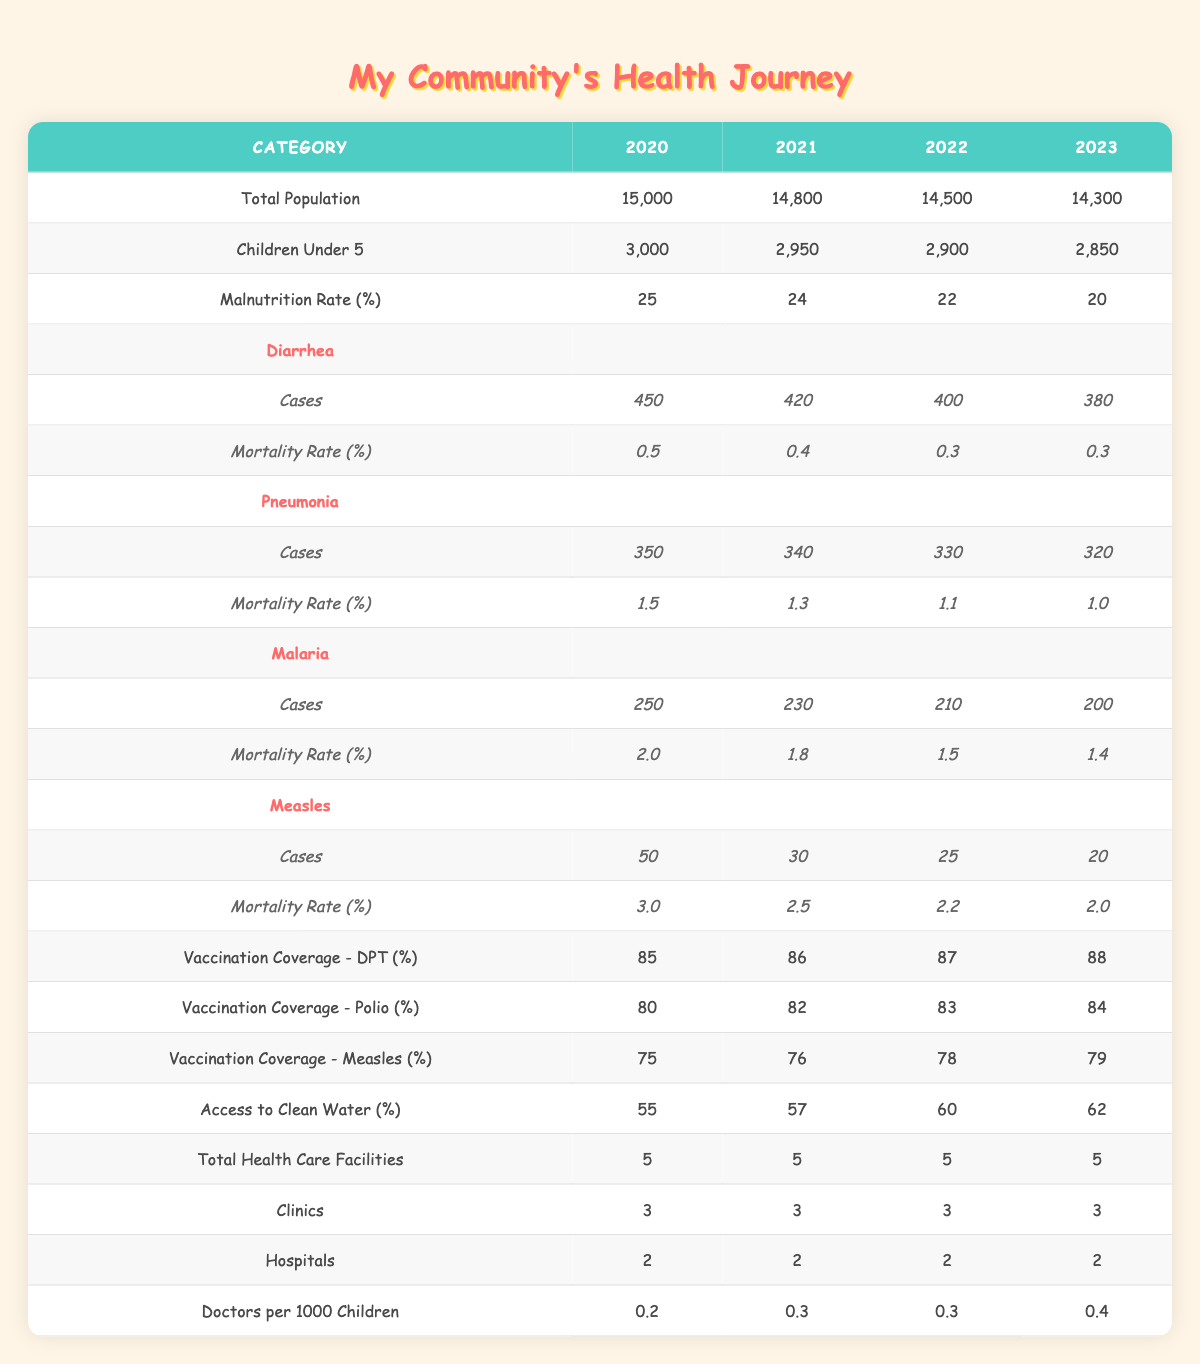What was the malnutrition rate in 2022? The malnutrition rate can be found in the table, specifically under the "Malnutrition Rate (%)" row for the year 2022. It shows a value of 22%.
Answer: 22% How many cases of pneumonia were reported in 2021? The number of pneumonia cases for the year 2021 can be retrieved from the "Pneumonia" section, where it states there were 340 cases in that year.
Answer: 340 What is the percentage of the total population under 5 years old in 2023? To find this percentage, I refer to the number of children under 5 (2,850) and total population (14,300) in 2023. The percentage is calculated as (2,850 / 14,300) * 100, which equals about 19.9%.
Answer: 19.9% What is the average mortality rate for measles over the four years? To calculate the average mortality rate for measles, we look at the mortality rates from 2020 to 2023: 3.0, 2.5, 2.2, and 2.0. Adding these values gives us 9.7, and dividing this by 4 (the number of years) results in an average of 2.425%.
Answer: 2.425% Did the access to clean water percentage improve from 2020 to 2023? To determine whether access to clean water improved, we compare the percentage in 2020 (55%) with that in 2023 (62%). Since 62% is greater than 55%, access to clean water has indeed improved.
Answer: Yes What is the total number of cases for diarrhea, pneumonia, malaria, and measles in 2022? To find the total cases, we add the reported cases of each illness for 2022: Diarrhea (400), Pneumonia (330), Malaria (210), and Measles (25). The total is 400 + 330 + 210 + 25 = 965.
Answer: 965 How many doctors are available per 1000 children in the community in 2023? The number of doctors per 1000 children in 2023 can be directly found in the "Doctors per 1000 Children" row for that year, which shows a value of 0.4.
Answer: 0.4 What was the trend for vaccination coverage for DPT from 2020 to 2023? Looking at the DPT vaccination coverage data in the table for the years 2020 (85%), 2021 (86%), 2022 (87%), and 2023 (88%), we see a steady increase each year. This indicates an upward trend.
Answer: Upward trend What are the total health care facilities in the community, and did it change over the four years? The total number of health care facilities was 5 each year from 2020 to 2023, meaning there was no change in the total count during that time period.
Answer: No change What was the case rate of malaria in 2022 compared to pneumonia in the same year? In 2022, there were 210 cases of malaria and 330 cases of pneumonia. Comparing these two shows that pneumonia cases (330) were higher than malaria cases (210).
Answer: Pneumonia was higher 